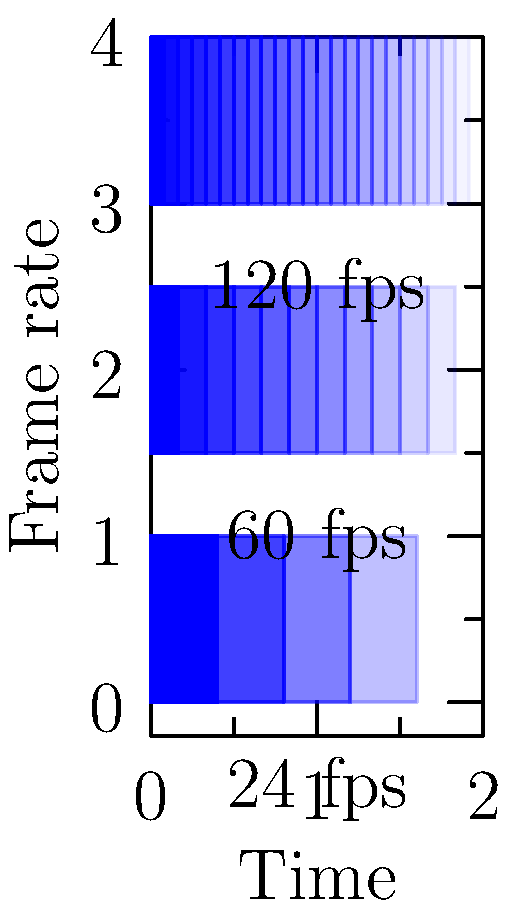As a pioneer in special effects technology, you're consulting on a new project that aims to achieve ultra-smooth motion in fast-paced action scenes. Given the motion blur examples for different frame rates shown in the diagram, which frame rate would you recommend for minimizing motion blur and why? To answer this question, let's analyze the motion blur examples for each frame rate:

1. 24 fps (frames per second):
   - This is the standard frame rate for traditional film.
   - The motion blur is most pronounced, with only 5 distinct frames visible.
   - More blur indicates less smooth motion, especially in fast-moving scenes.

2. 60 fps:
   - This is a common frame rate for high-end displays and some video games.
   - The motion blur is noticeably reduced, with 12 distinct frames visible.
   - This provides smoother motion than 24 fps, but some blur is still present.

3. 120 fps:
   - This is a high frame rate used in some advanced displays and VFX work.
   - The motion blur is minimal, with 24 distinct frames visible.
   - This results in very smooth motion, even in fast-paced scenes.

In visual effects, higher frame rates offer several advantages:
- Reduced motion blur: As seen in the diagram, higher frame rates result in less motion blur, which is crucial for maintaining clarity in fast-moving scenes.
- Smoother motion: More frames per second create a more fluid and realistic representation of motion.
- Enhanced detail: With less blur between frames, fine details are preserved even during rapid movement.
- Improved slow-motion effects: Higher frame rates allow for smoother slow-motion playback without loss of quality.

Given these factors, the 120 fps option would be the most suitable for minimizing motion blur and achieving ultra-smooth motion in fast-paced action scenes. It provides the clearest representation of movement with the least amount of blur, allowing for more precise and detailed visual effects.
Answer: 120 fps, as it minimizes motion blur and provides the smoothest motion for fast-paced scenes. 